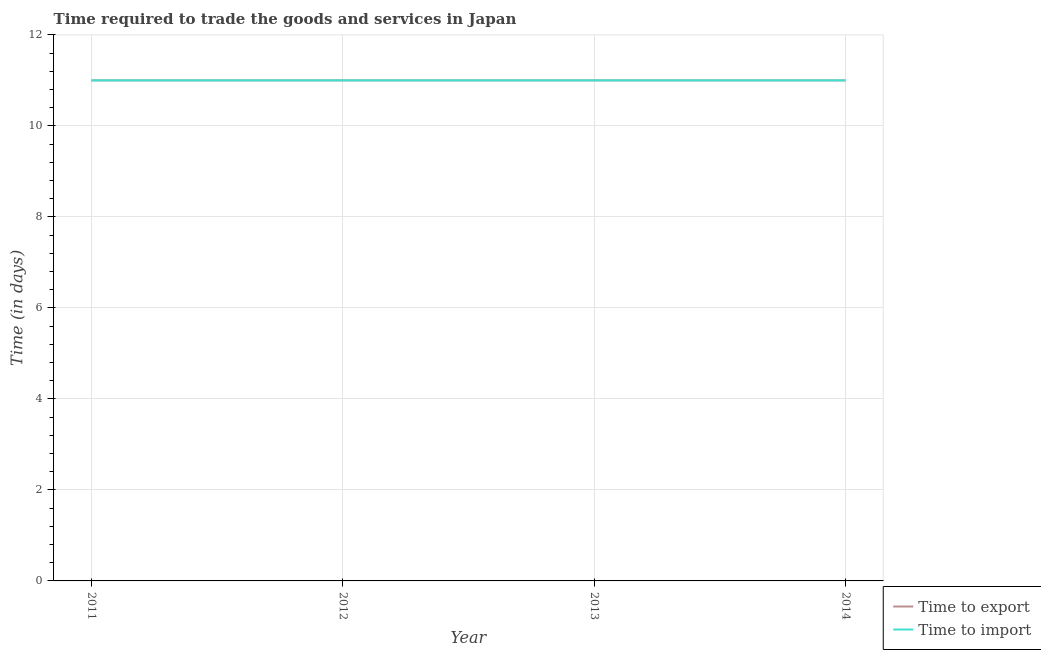Is the number of lines equal to the number of legend labels?
Make the answer very short. Yes. What is the time to import in 2012?
Your answer should be compact. 11. Across all years, what is the maximum time to import?
Your response must be concise. 11. Across all years, what is the minimum time to import?
Provide a succinct answer. 11. In which year was the time to import minimum?
Offer a very short reply. 2011. What is the total time to import in the graph?
Your answer should be very brief. 44. What is the average time to export per year?
Provide a succinct answer. 11. In the year 2013, what is the difference between the time to import and time to export?
Your answer should be very brief. 0. What is the ratio of the time to export in 2012 to that in 2014?
Offer a terse response. 1. What is the difference between the highest and the second highest time to import?
Offer a terse response. 0. In how many years, is the time to export greater than the average time to export taken over all years?
Give a very brief answer. 0. Are the values on the major ticks of Y-axis written in scientific E-notation?
Offer a very short reply. No. Does the graph contain any zero values?
Your answer should be very brief. No. Where does the legend appear in the graph?
Ensure brevity in your answer.  Bottom right. How are the legend labels stacked?
Provide a succinct answer. Vertical. What is the title of the graph?
Provide a succinct answer. Time required to trade the goods and services in Japan. What is the label or title of the Y-axis?
Your response must be concise. Time (in days). What is the Time (in days) of Time to export in 2011?
Provide a short and direct response. 11. What is the Time (in days) in Time to export in 2012?
Your answer should be compact. 11. What is the Time (in days) in Time to import in 2013?
Your answer should be very brief. 11. What is the Time (in days) of Time to export in 2014?
Provide a succinct answer. 11. What is the Time (in days) of Time to import in 2014?
Offer a terse response. 11. Across all years, what is the maximum Time (in days) of Time to export?
Keep it short and to the point. 11. Across all years, what is the maximum Time (in days) in Time to import?
Offer a very short reply. 11. Across all years, what is the minimum Time (in days) in Time to export?
Offer a terse response. 11. Across all years, what is the minimum Time (in days) in Time to import?
Provide a succinct answer. 11. What is the total Time (in days) in Time to export in the graph?
Offer a terse response. 44. What is the total Time (in days) of Time to import in the graph?
Provide a succinct answer. 44. What is the difference between the Time (in days) in Time to import in 2011 and that in 2012?
Provide a short and direct response. 0. What is the difference between the Time (in days) of Time to import in 2011 and that in 2013?
Your answer should be compact. 0. What is the difference between the Time (in days) of Time to import in 2011 and that in 2014?
Your response must be concise. 0. What is the difference between the Time (in days) in Time to export in 2012 and that in 2013?
Your response must be concise. 0. What is the difference between the Time (in days) in Time to import in 2012 and that in 2013?
Your answer should be compact. 0. What is the difference between the Time (in days) in Time to export in 2012 and that in 2014?
Your answer should be compact. 0. What is the difference between the Time (in days) of Time to export in 2013 and that in 2014?
Ensure brevity in your answer.  0. What is the difference between the Time (in days) in Time to import in 2013 and that in 2014?
Make the answer very short. 0. What is the difference between the Time (in days) in Time to export in 2011 and the Time (in days) in Time to import in 2012?
Ensure brevity in your answer.  0. What is the difference between the Time (in days) in Time to export in 2011 and the Time (in days) in Time to import in 2013?
Your answer should be compact. 0. What is the difference between the Time (in days) in Time to export in 2011 and the Time (in days) in Time to import in 2014?
Your answer should be very brief. 0. What is the difference between the Time (in days) in Time to export in 2012 and the Time (in days) in Time to import in 2013?
Offer a very short reply. 0. What is the difference between the Time (in days) of Time to export in 2012 and the Time (in days) of Time to import in 2014?
Offer a terse response. 0. What is the difference between the Time (in days) in Time to export in 2013 and the Time (in days) in Time to import in 2014?
Give a very brief answer. 0. What is the average Time (in days) in Time to import per year?
Ensure brevity in your answer.  11. In the year 2012, what is the difference between the Time (in days) of Time to export and Time (in days) of Time to import?
Your answer should be very brief. 0. In the year 2013, what is the difference between the Time (in days) of Time to export and Time (in days) of Time to import?
Keep it short and to the point. 0. In the year 2014, what is the difference between the Time (in days) of Time to export and Time (in days) of Time to import?
Your response must be concise. 0. What is the ratio of the Time (in days) of Time to export in 2011 to that in 2012?
Provide a short and direct response. 1. What is the ratio of the Time (in days) of Time to export in 2011 to that in 2014?
Make the answer very short. 1. What is the ratio of the Time (in days) of Time to import in 2012 to that in 2014?
Your answer should be compact. 1. What is the ratio of the Time (in days) of Time to export in 2013 to that in 2014?
Give a very brief answer. 1. What is the ratio of the Time (in days) of Time to import in 2013 to that in 2014?
Ensure brevity in your answer.  1. 